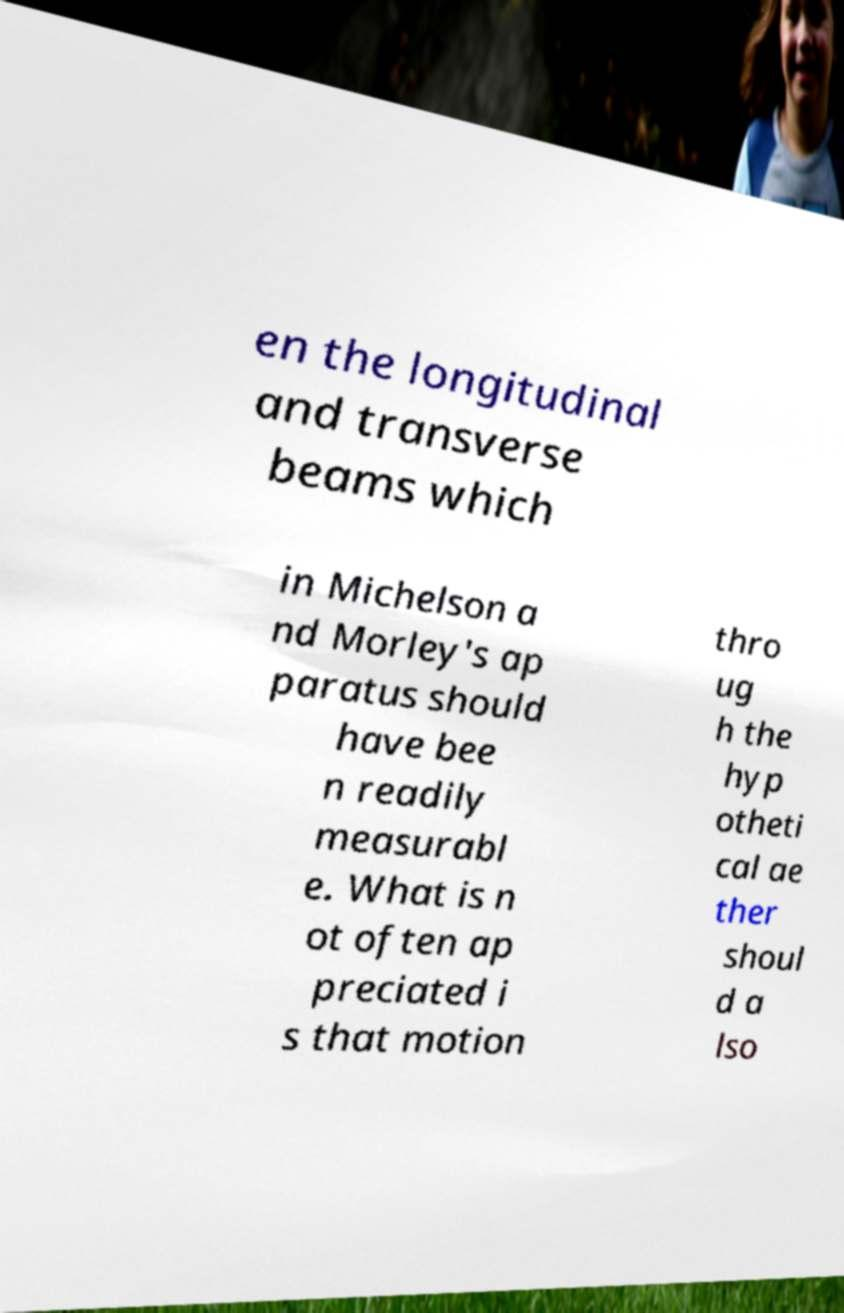Can you read and provide the text displayed in the image?This photo seems to have some interesting text. Can you extract and type it out for me? en the longitudinal and transverse beams which in Michelson a nd Morley's ap paratus should have bee n readily measurabl e. What is n ot often ap preciated i s that motion thro ug h the hyp otheti cal ae ther shoul d a lso 